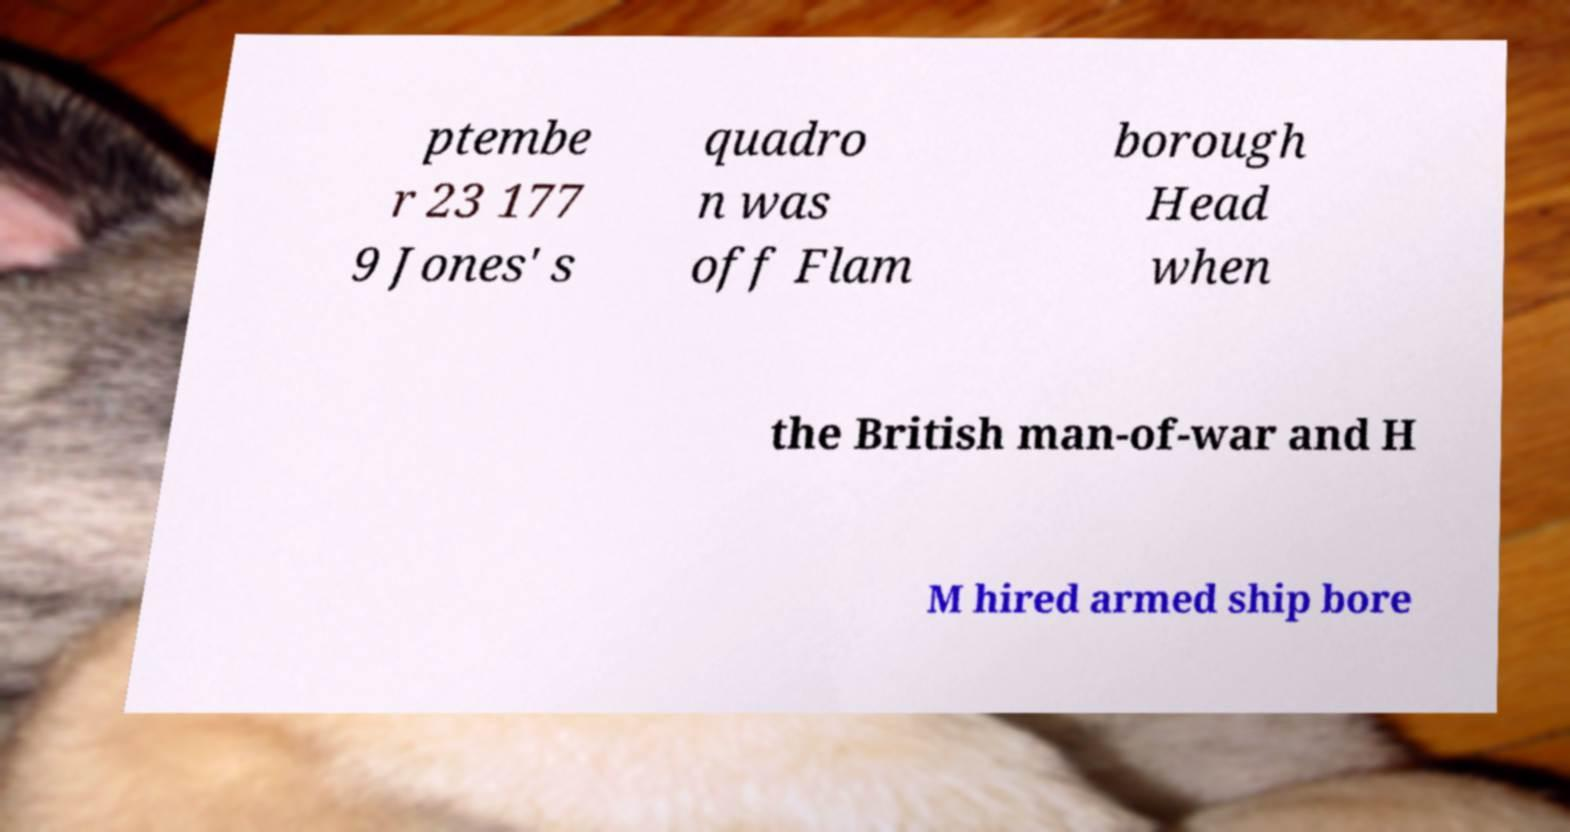Can you read and provide the text displayed in the image?This photo seems to have some interesting text. Can you extract and type it out for me? ptembe r 23 177 9 Jones' s quadro n was off Flam borough Head when the British man-of-war and H M hired armed ship bore 